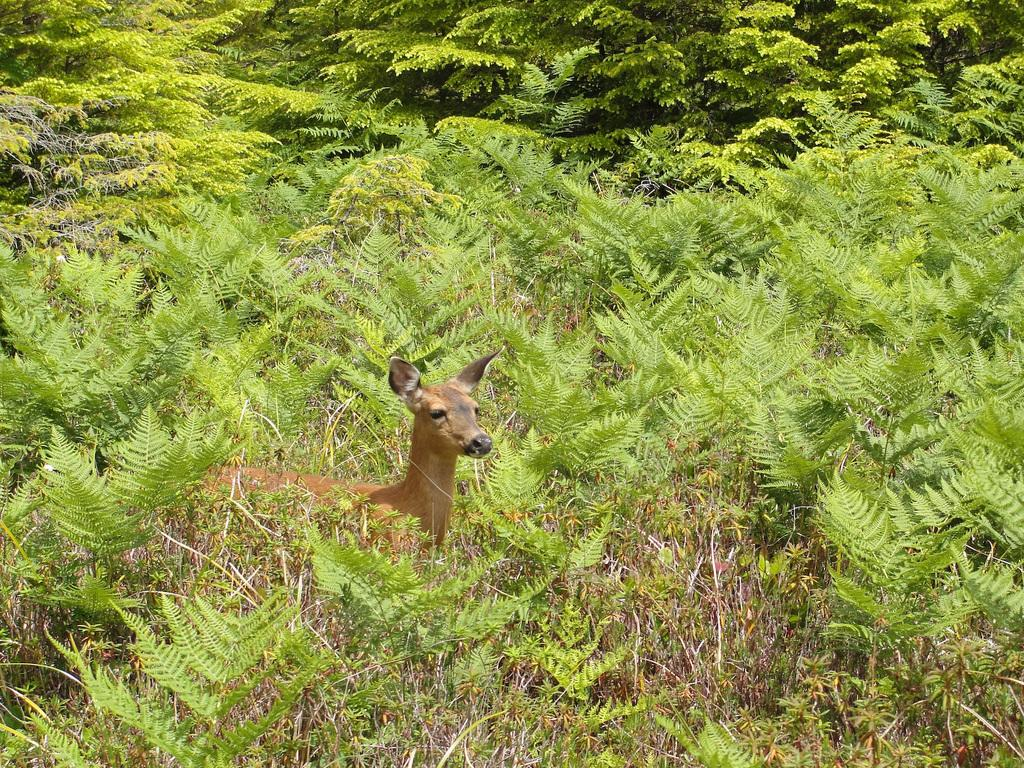What type of creature is present in the image? There is an animal in the image. What color is the animal? The animal is brown in color. Where is the animal located in relation to other objects in the image? The animal is between plants. What can be seen in the background of the image? There are many trees in the background of the image. How many cakes does the animal have a grip on in the image? There are no cakes present in the image, and the animal is not shown gripping anything. 